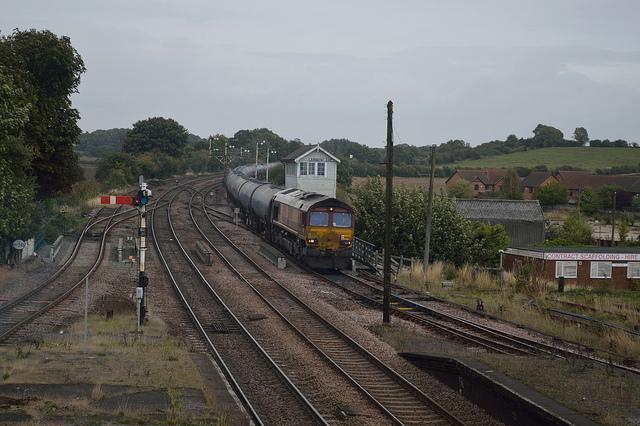How many tracks are visible?
Give a very brief answer. 4. How many windows does the front of the train have?
Give a very brief answer. 2. How many train tracks is there?
Give a very brief answer. 4. How many rail tracks are there?
Give a very brief answer. 4. How many train tracks can be seen?
Give a very brief answer. 4. How many train tracks are there?
Give a very brief answer. 4. 